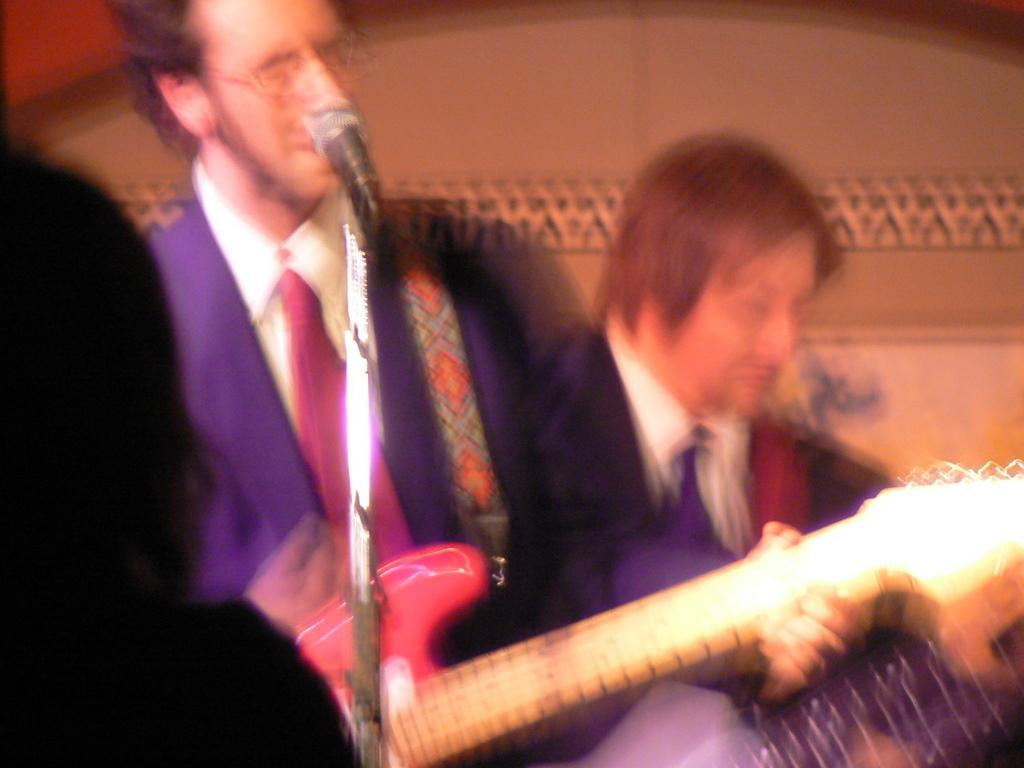What is the man in the image doing? The man is singing on a microphone and playing a guitar. What can be seen on the man's face? The man is wearing spectacles. What type of clothing is the man wearing? The man is wearing a suit. What is visible in the background of the image? There is a wall in the background of the image. What type of volleyball is the man playing in the image? There is no volleyball present in the image; the man is singing and playing a guitar. What type of poison can be seen in the image? There is no poison present in the image. 